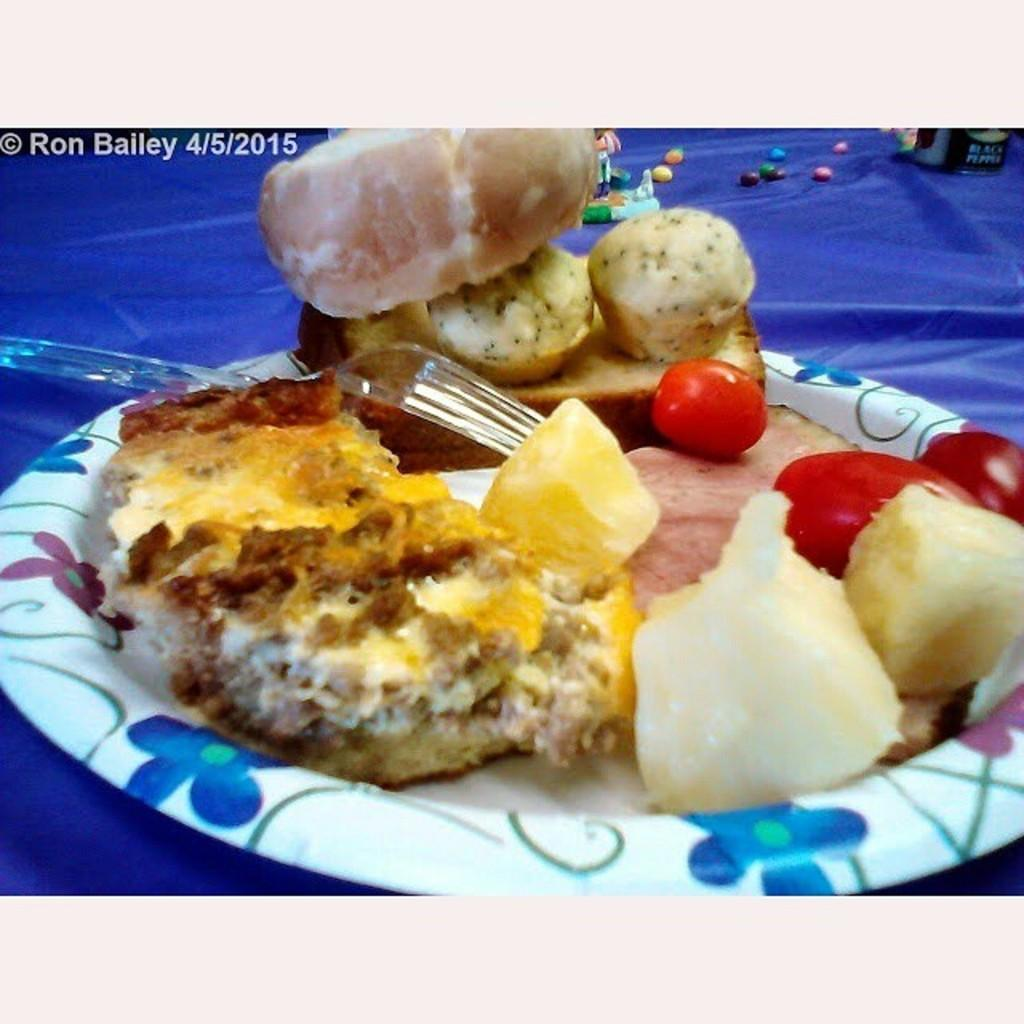What is present on the surface in the image? There is a plate in the image. What is beneath the plate? There is a cloth below the plate. What can be found on the cloth? There are objects on the cloth. What utensil is visible in the image? There is a fork in the image. What type of rock is visible on the cloth in the image? There is no rock present on the cloth in the image. How many patches can be seen on the cloth in the image? There is no mention of patches on the cloth in the image. 